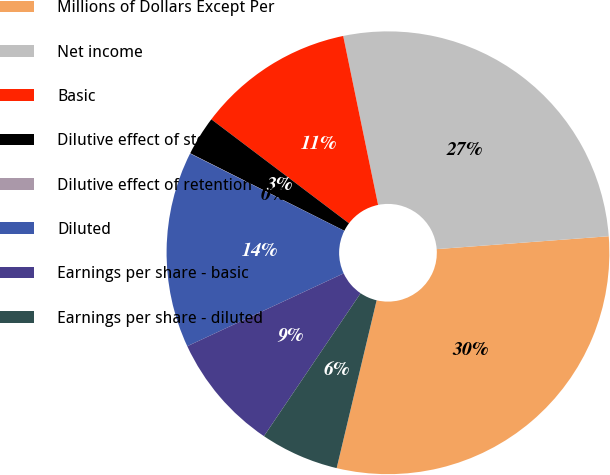Convert chart. <chart><loc_0><loc_0><loc_500><loc_500><pie_chart><fcel>Millions of Dollars Except Per<fcel>Net income<fcel>Basic<fcel>Dilutive effect of stock<fcel>Dilutive effect of retention<fcel>Diluted<fcel>Earnings per share - basic<fcel>Earnings per share - diluted<nl><fcel>29.91%<fcel>27.05%<fcel>11.46%<fcel>2.88%<fcel>0.02%<fcel>14.33%<fcel>8.6%<fcel>5.74%<nl></chart> 